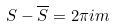<formula> <loc_0><loc_0><loc_500><loc_500>S - \overline { S } = 2 \pi i m</formula> 